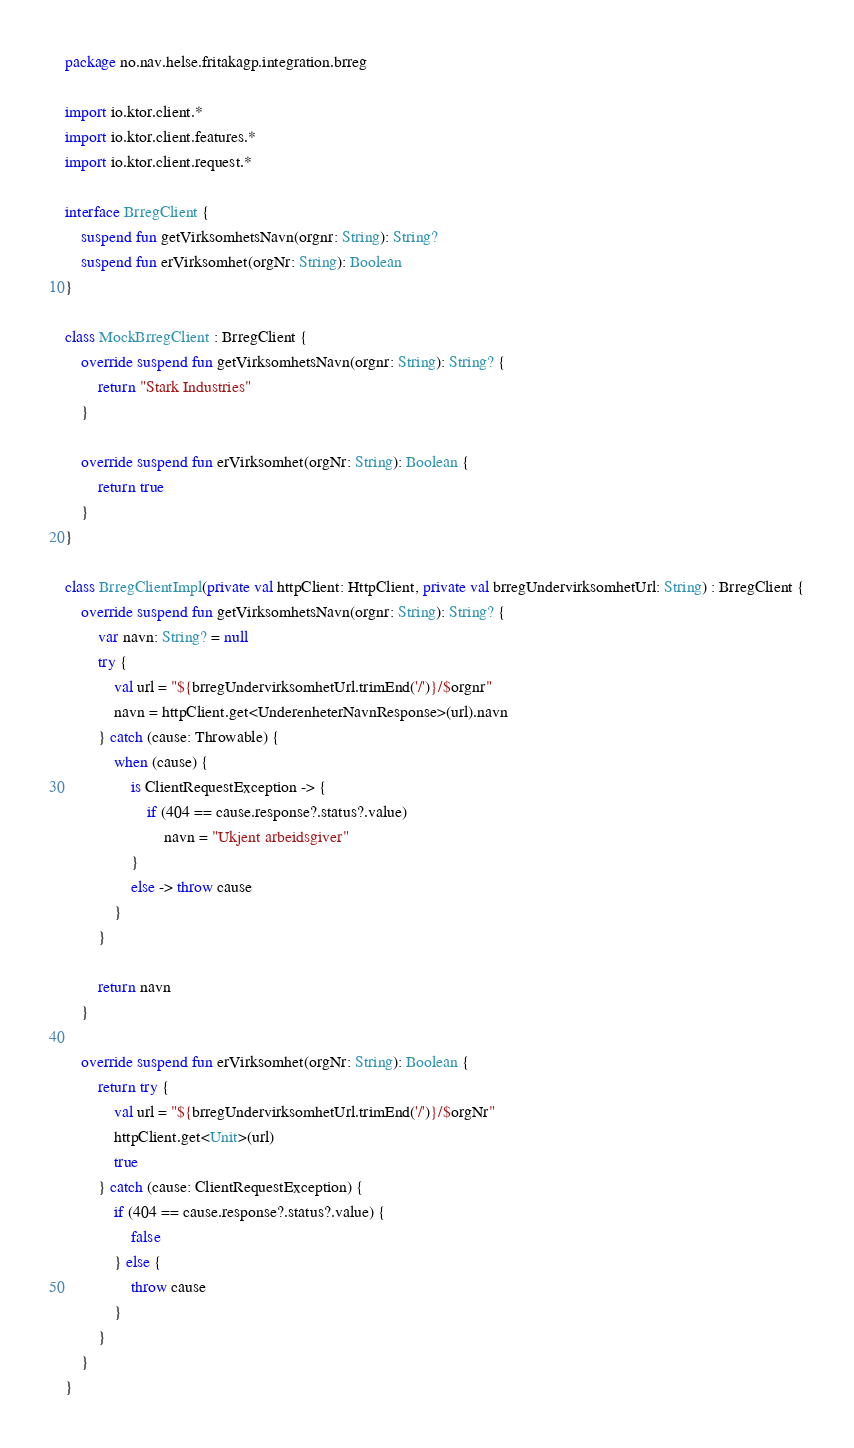<code> <loc_0><loc_0><loc_500><loc_500><_Kotlin_>package no.nav.helse.fritakagp.integration.brreg

import io.ktor.client.*
import io.ktor.client.features.*
import io.ktor.client.request.*

interface BrregClient {
    suspend fun getVirksomhetsNavn(orgnr: String): String?
    suspend fun erVirksomhet(orgNr: String): Boolean
}

class MockBrregClient : BrregClient {
    override suspend fun getVirksomhetsNavn(orgnr: String): String? {
        return "Stark Industries"
    }

    override suspend fun erVirksomhet(orgNr: String): Boolean {
        return true
    }
}

class BrregClientImpl(private val httpClient: HttpClient, private val brregUndervirksomhetUrl: String) : BrregClient {
    override suspend fun getVirksomhetsNavn(orgnr: String): String? {
        var navn: String? = null
        try {
            val url = "${brregUndervirksomhetUrl.trimEnd('/')}/$orgnr"
            navn = httpClient.get<UnderenheterNavnResponse>(url).navn
        } catch (cause: Throwable) {
            when (cause) {
                is ClientRequestException -> {
                    if (404 == cause.response?.status?.value)
                        navn = "Ukjent arbeidsgiver"
                }
                else -> throw cause
            }
        }

        return navn
    }

    override suspend fun erVirksomhet(orgNr: String): Boolean {
        return try {
            val url = "${brregUndervirksomhetUrl.trimEnd('/')}/$orgNr"
            httpClient.get<Unit>(url)
            true
        } catch (cause: ClientRequestException) {
            if (404 == cause.response?.status?.value) {
                false
            } else {
                throw cause
            }
        }
    }
}</code> 